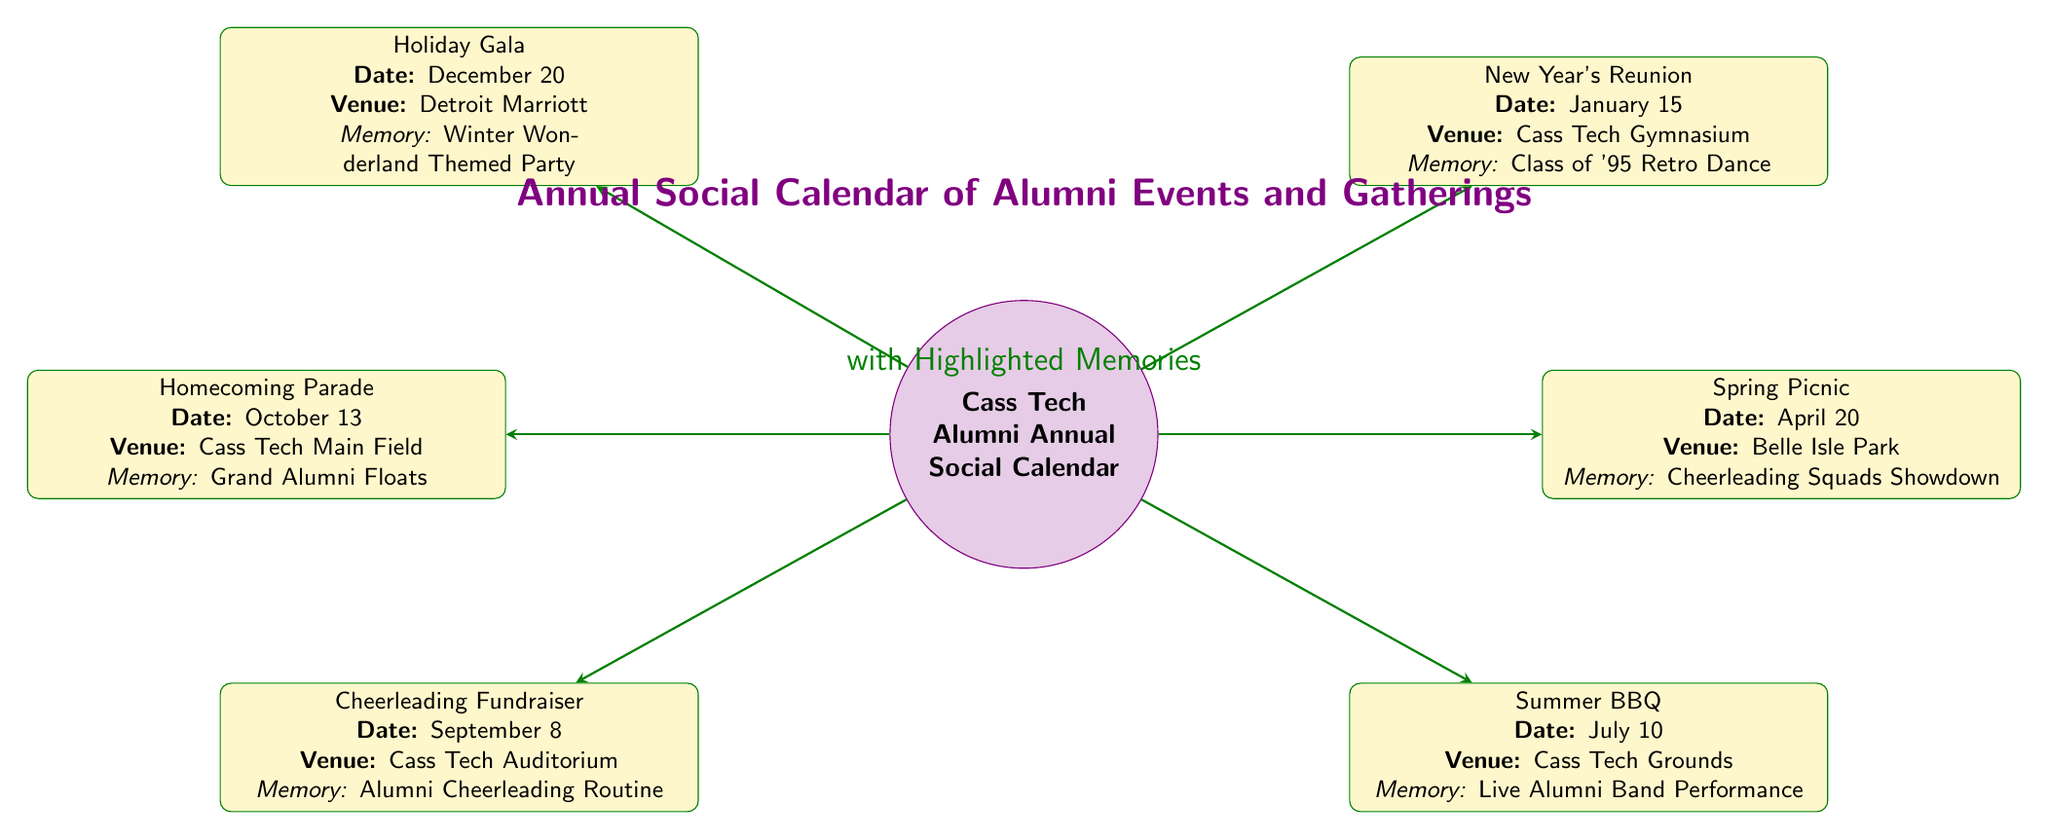What's the date of the New Year's Reunion? The diagram specifies the date of the New Year's Reunion event as January 15, located next to the event name in the corresponding node.
Answer: January 15 How many events are listed in the diagram? The diagram showcases a total of six events connected to the central node, each representing a different alumni gathering throughout the year.
Answer: Six Where is the Holiday Gala held? According to the diagram, the Holiday Gala is set to take place at the Detroit Marriott, which is mentioned in the event's details within its node.
Answer: Detroit Marriott Which event features a class of '95 retro dance? The diagram indicates that the New Year's Reunion is associated with the memory of the Class of '95 Retro Dance, directly stated in the corresponding event node.
Answer: New Year's Reunion What is the memory associated with the Cheerleading Fundraiser event? The diagram specifies that the Cheerleading Fundraiser is linked to the memory of the Alumni Cheerleading Routine, making this detail clear in the event's respective node.
Answer: Alumni Cheerleading Routine Which event takes place at the Cass Tech Gymnasium? The New Year's Reunion is the event that takes place at Cass Tech Gymnasium, as indicated in the event node's venue detail.
Answer: New Year's Reunion What event occurs before the Summer BBQ? The diagram lists the Spring Picnic as occurring before the Summer BBQ in chronological order, as evidenced by their respective dates in the event nodes.
Answer: Spring Picnic What type of event is planned for October? The event scheduled for October is the Homecoming Parade, which is highlighted in the diagram under that month.
Answer: Homecoming Parade 